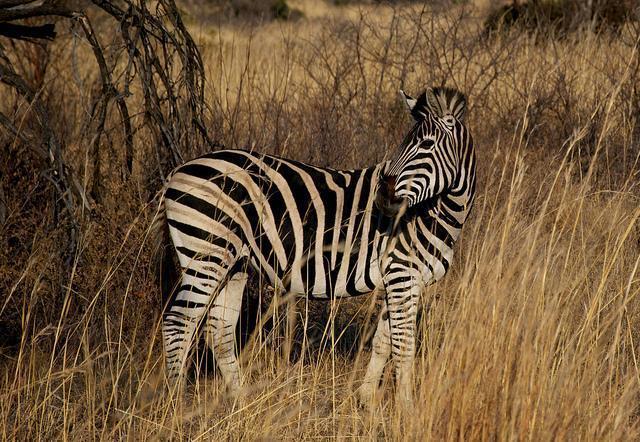How many zebras?
Give a very brief answer. 1. How many zebras are in the photo?
Give a very brief answer. 1. 